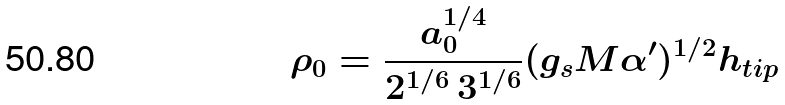Convert formula to latex. <formula><loc_0><loc_0><loc_500><loc_500>\rho _ { 0 } = \frac { a _ { 0 } ^ { 1 / 4 } } { 2 ^ { 1 / 6 } \, 3 ^ { 1 / 6 } } ( g _ { s } M \alpha ^ { \prime } ) ^ { 1 / 2 } h _ { t i p }</formula> 